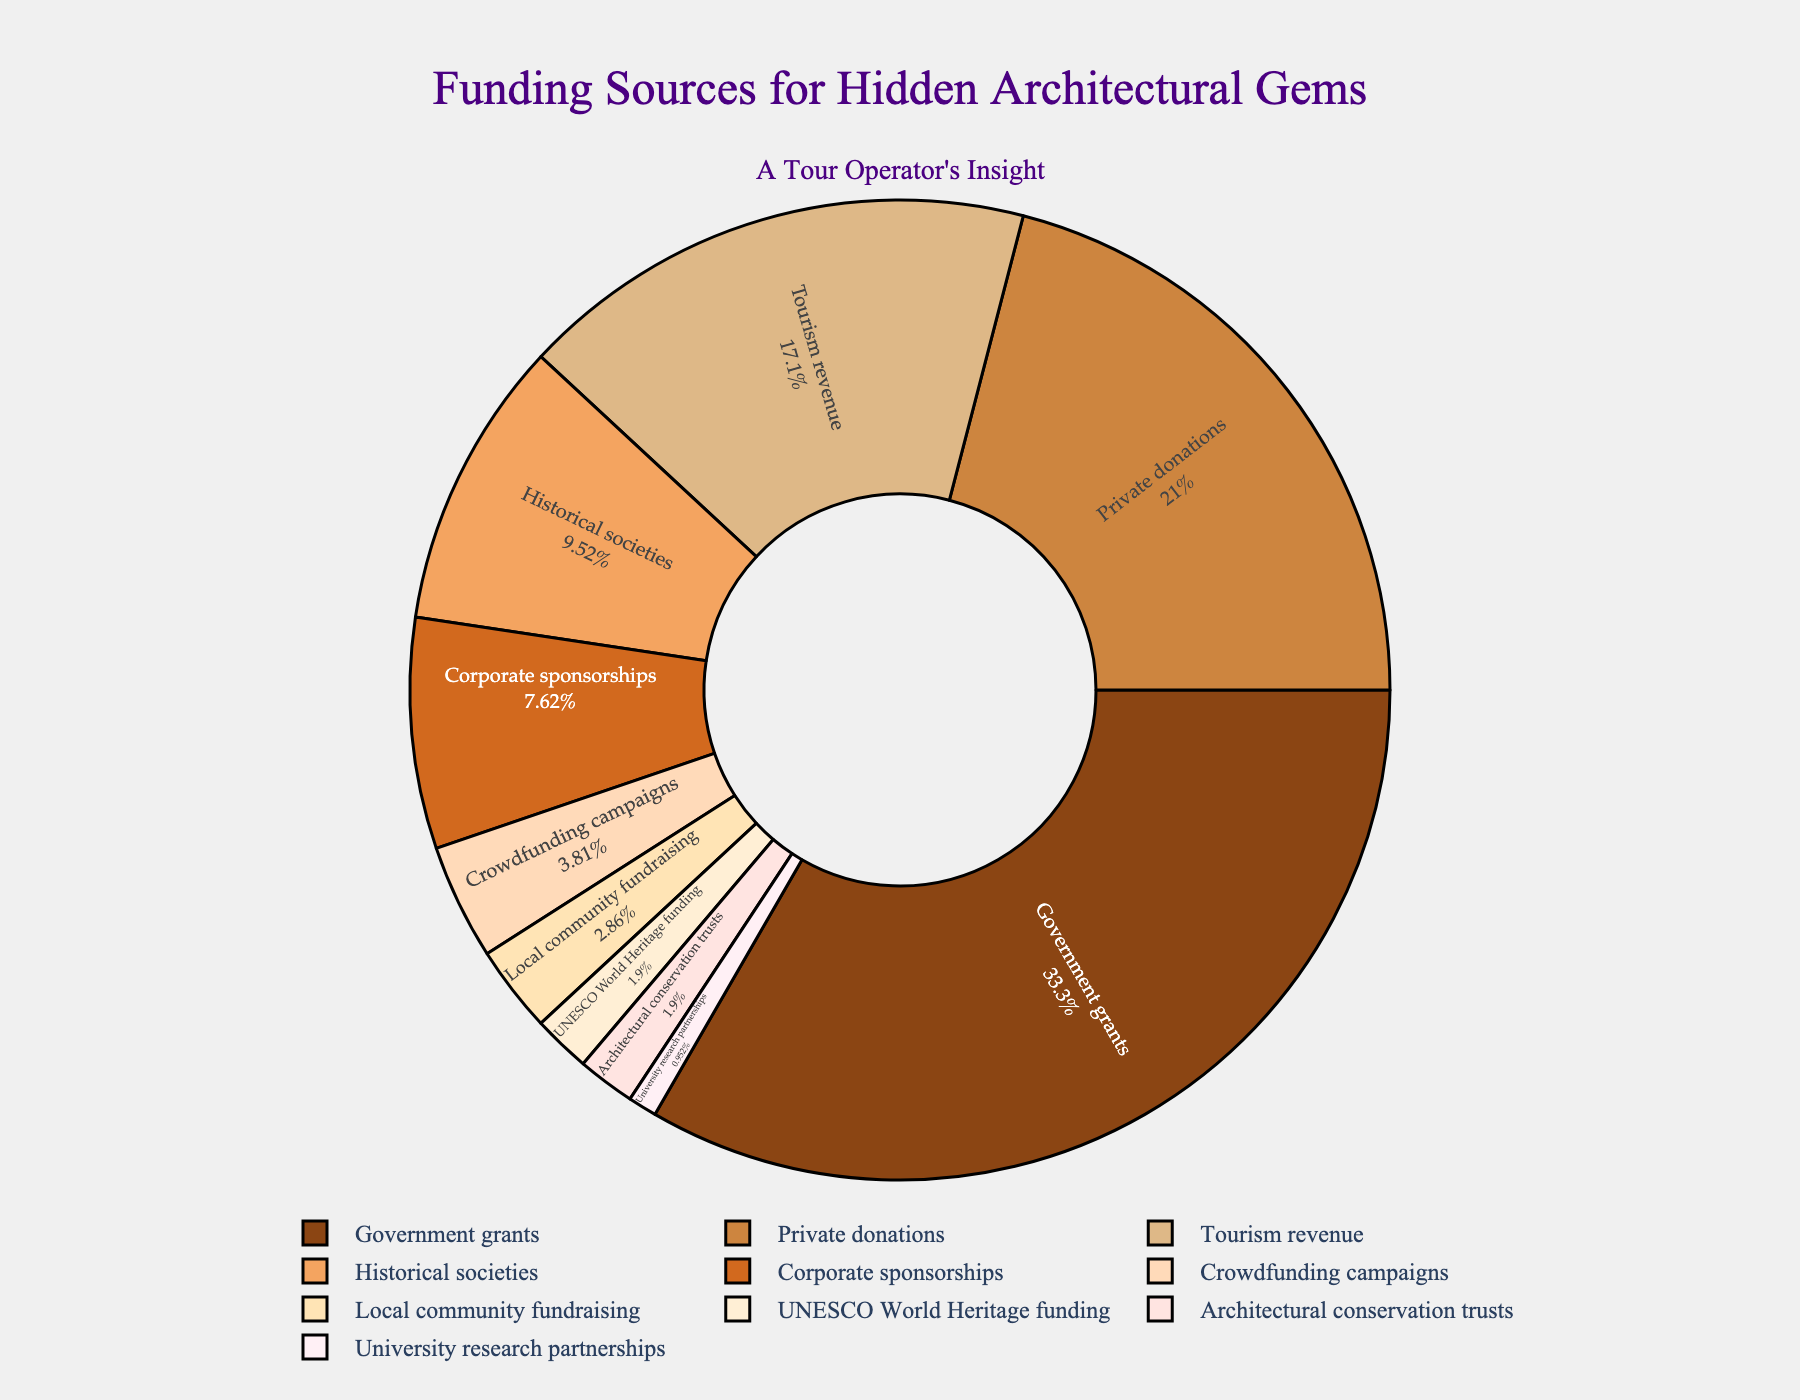How much more percentage does the Government grants category have over the Corporate sponsorships category? The Government grants category has a percentage of 35%. The Corporate sponsorships category has a percentage of 8%. The difference is calculated as 35% - 8% = 27%.
Answer: 27% Compare the combined percentage of University research partnerships and UNESCO World Heritage funding to that of Crowdfunding campaigns. Which one is higher? University research partnerships have 1%, and UNESCO World Heritage funding has 2%. Their combined percentage is 1% + 2% = 3%. Crowdfunding campaigns have 4%. Comparing the two, 4% (Crowdfunding campaigns) is higher than 3% (combined).
Answer: Crowdfunding campaigns Which category contributes the least to the funding sources? The category with the smallest percentage is University research partnerships at 1%.
Answer: University research partnerships What is the total percentage of funding coming from organizational sources (i.e., Government grants, Historical societies, UNESCO World Heritage funding, Architectural conservation trusts, University research partnerships)? Summing the percentages from these categories: Government grants (35%), Historical societies (10%), UNESCO World Heritage funding (2%), Architectural conservation trusts (2%), and University research partnerships (1%) gives a total of 35% + 10% + 2% + 2% + 1% = 50%.
Answer: 50% Which two categories combined have a similar percentage to Private donations? Private donations have a percentage of 22%. Tourism revenue (18%) and Local community fundraising (3%) combined are 18% + 3% = 21%, which is close to 22%.
Answer: Tourism revenue and Local community fundraising What is the second-largest funding source and by how much does it fall short of the largest? The second-largest funding source is Private donations at 22%. The largest is Government grants at 35%. The shortfall is 35% - 22% = 13%.
Answer: 13% What is the sum percentage of all funding sources that contribute less than 5% each? The categories contributing less than 5% are Crowdfunding campaigns (4%), Local community fundraising (3%), UNESCO World Heritage funding (2%), Architectural conservation trusts (2%), and University research partnerships (1%). Summing these: 4% + 3% + 2% + 2% + 1% = 12%.
Answer: 12% Which funding source category has a percentage closest to that of Tourism revenue? Tourism revenue has a percentage of 18%. The closest percentage is Historical societies at 10%, which differs by 8%.
Answer: Historical societies What is the combined percentage of Corporate sponsorships, Crowdfunding campaigns, and Local community fundraising? Adding their percentages: Corporate sponsorships (8%), Crowdfunding campaigns (4%), and Local community fundraising (3%) gives 8% + 4% + 3% = 15%.
Answer: 15% Compare the total contributions from private (Private donations, Corporate sponsorships, Crowdfunding campaigns, Local community fundraising) versus governmental (Government grants and UNESCO World Heritage funding) sources. Which is higher, and by how much? The private sources total: 22% (Private donations) + 8% (Corporate sponsorships) + 4% (Crowdfunding campaigns) + 3% (Local community fundraising) = 37%. The governmental sources total: 35% (Government grants) + 2% (UNESCO World Heritage funding) = 37%. Both are equal.
Answer: Equal 